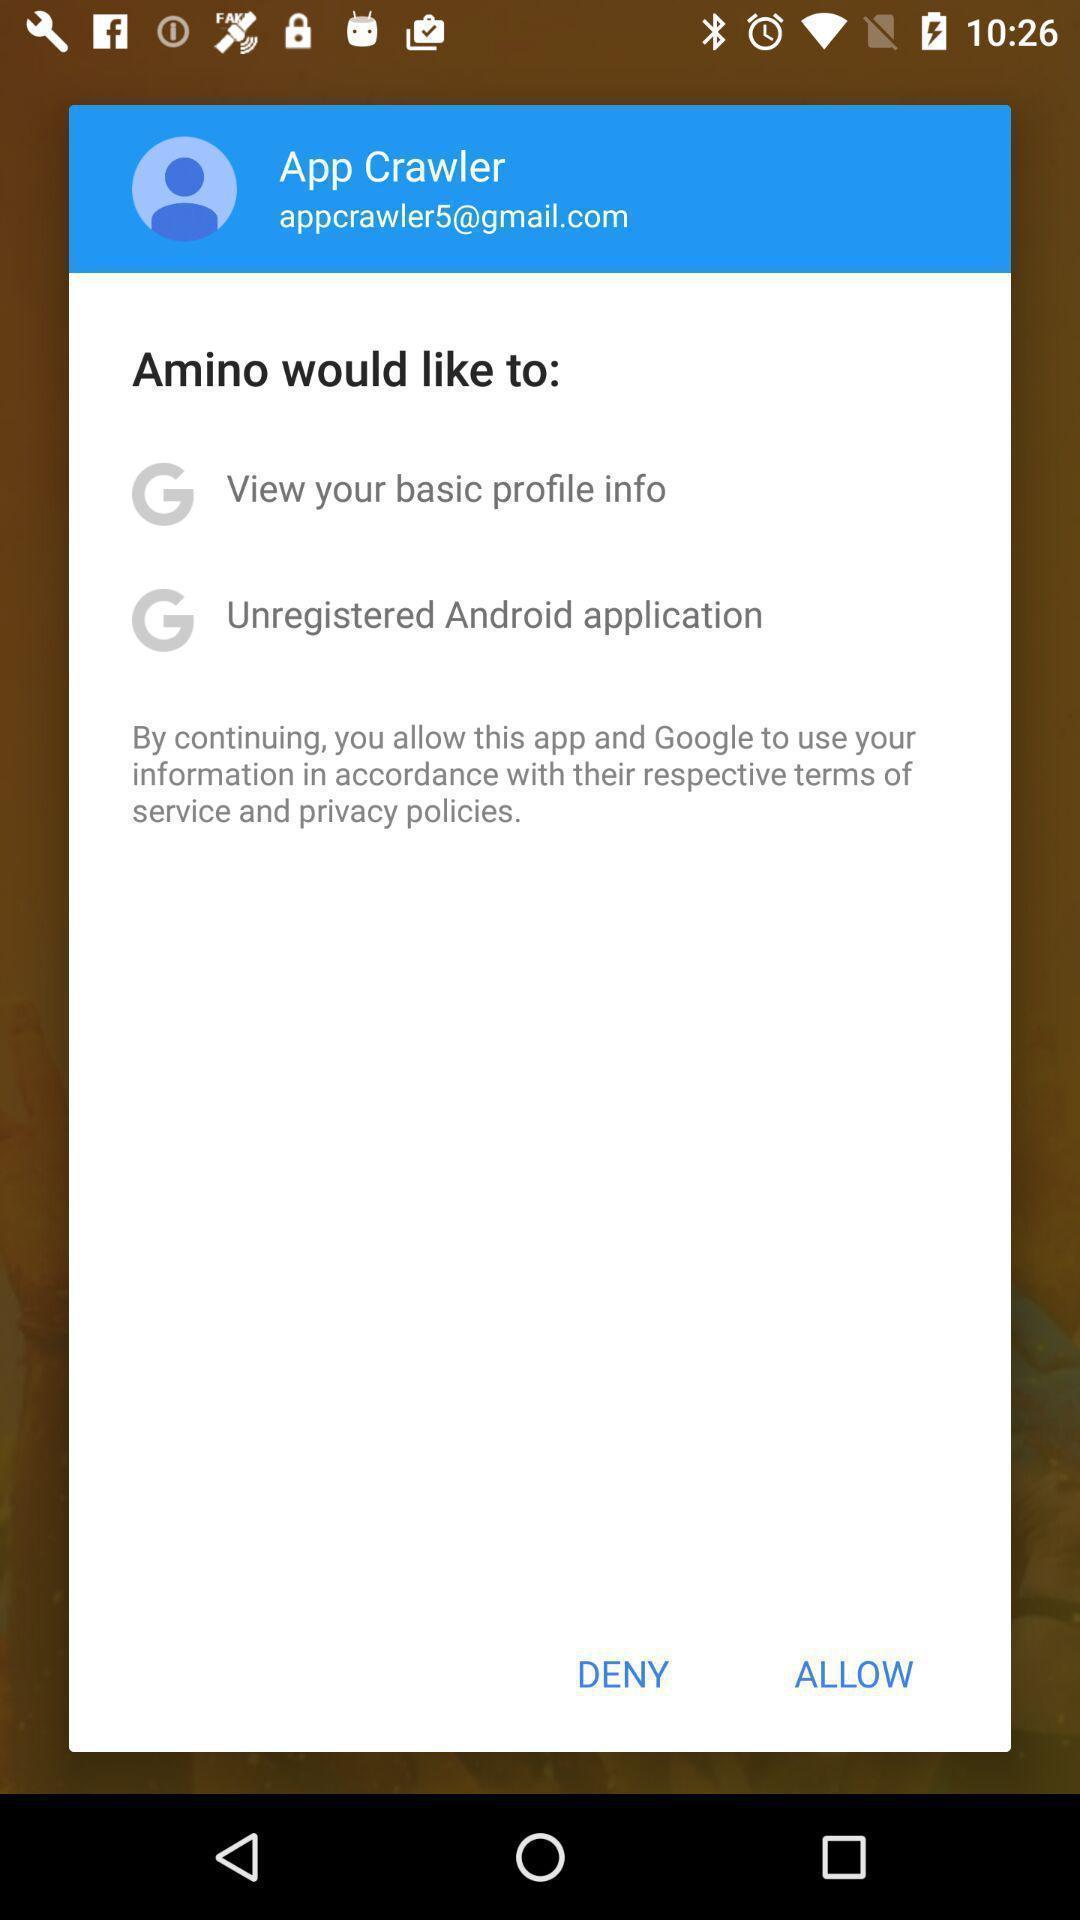What can you discern from this picture? Pop-up window asking to allow two settings. 